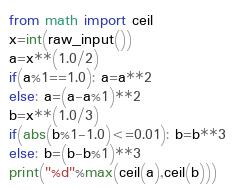Convert code to text. <code><loc_0><loc_0><loc_500><loc_500><_Python_>from math import ceil
x=int(raw_input())
a=x**(1.0/2)
if(a%1==1.0): a=a**2
else: a=(a-a%1)**2
b=x**(1.0/3)
if(abs(b%1-1.0)<=0.01): b=b**3
else: b=(b-b%1)**3
print("%d"%max(ceil(a),ceil(b)))</code> 